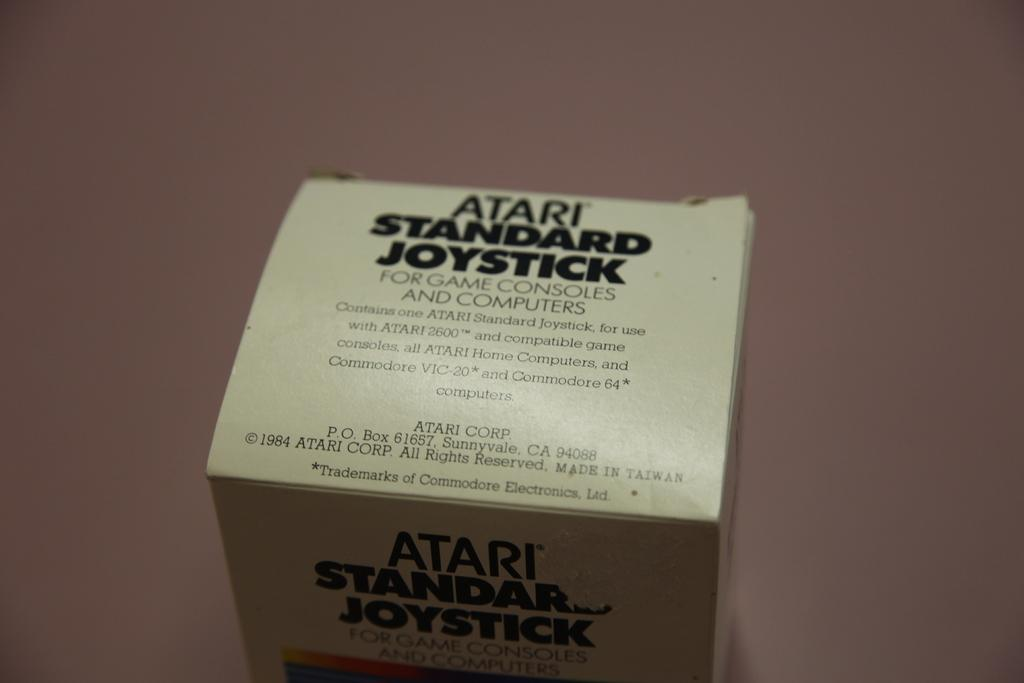<image>
Offer a succinct explanation of the picture presented. The box has the words Atari Standard Joystick on it. 